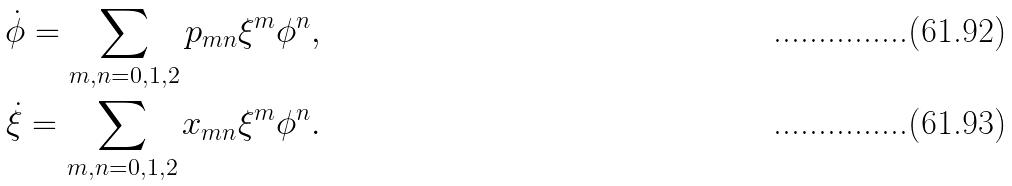Convert formula to latex. <formula><loc_0><loc_0><loc_500><loc_500>\dot { \phi } = \sum _ { m , n = 0 , 1 , 2 } p _ { m n } \xi ^ { m } \phi ^ { n } , \\ \dot { \xi } = \sum _ { m , n = 0 , 1 , 2 } x _ { m n } \xi ^ { m } \phi ^ { n } .</formula> 